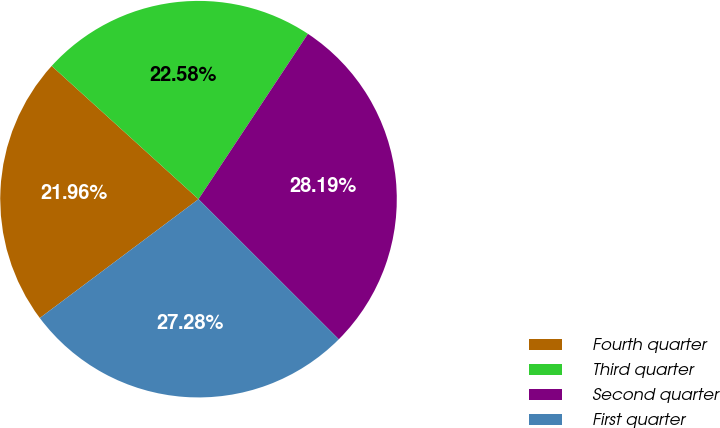Convert chart to OTSL. <chart><loc_0><loc_0><loc_500><loc_500><pie_chart><fcel>Fourth quarter<fcel>Third quarter<fcel>Second quarter<fcel>First quarter<nl><fcel>21.96%<fcel>22.58%<fcel>28.19%<fcel>27.28%<nl></chart> 